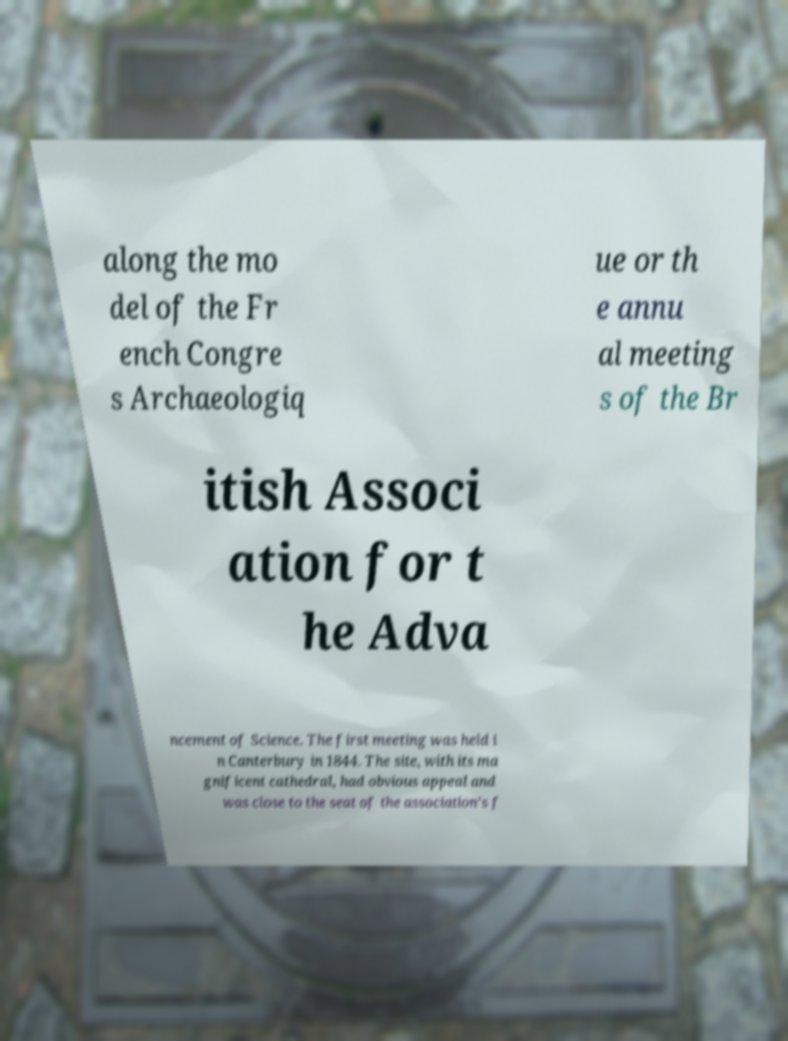Please identify and transcribe the text found in this image. along the mo del of the Fr ench Congre s Archaeologiq ue or th e annu al meeting s of the Br itish Associ ation for t he Adva ncement of Science. The first meeting was held i n Canterbury in 1844. The site, with its ma gnificent cathedral, had obvious appeal and was close to the seat of the association’s f 